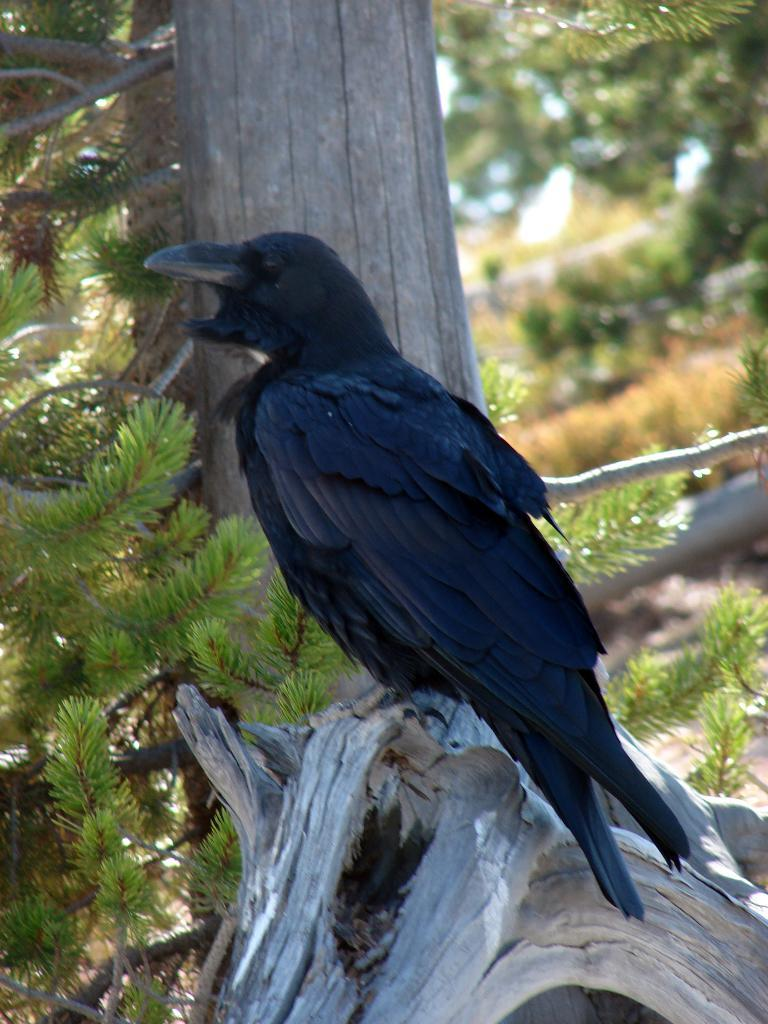What type of animal can be seen in the image? There is a bird in the image. Where is the bird located? The bird is on the branch of a tree. What can be seen in the background of the image? There are trees in the background of the image. What type of key is the bird holding in its beak in the image? There is no key present in the image; the bird is simply perched on a tree branch. 